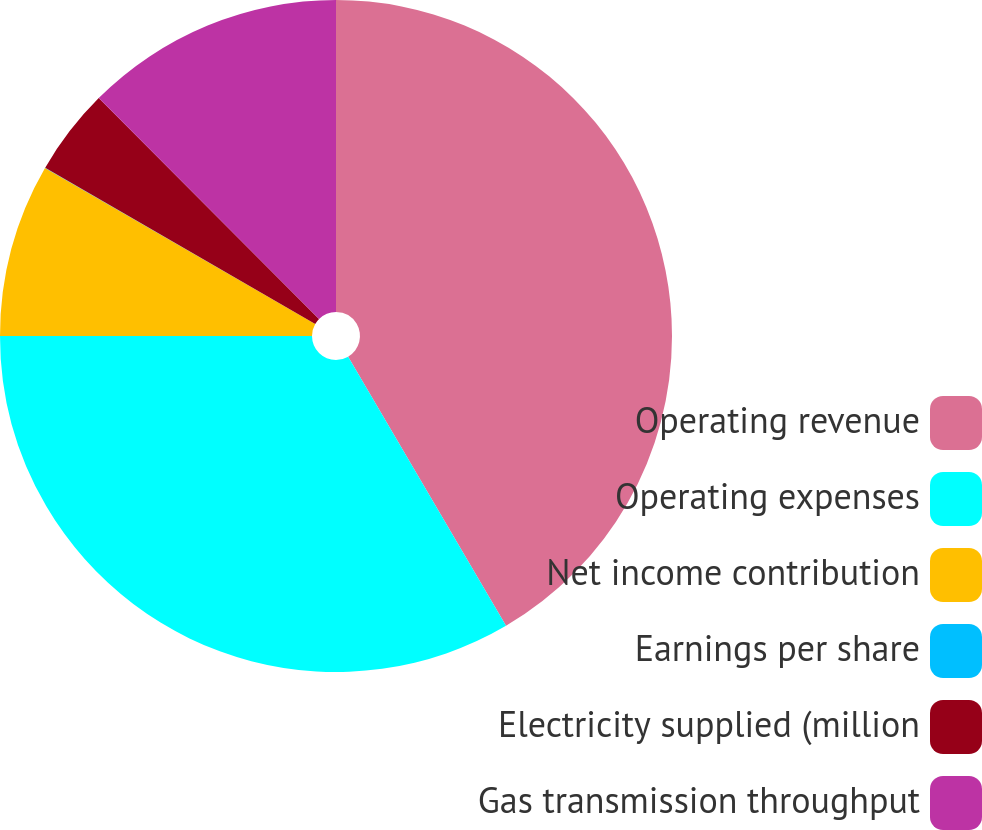<chart> <loc_0><loc_0><loc_500><loc_500><pie_chart><fcel>Operating revenue<fcel>Operating expenses<fcel>Net income contribution<fcel>Earnings per share<fcel>Electricity supplied (million<fcel>Gas transmission throughput<nl><fcel>41.56%<fcel>33.45%<fcel>8.33%<fcel>0.02%<fcel>4.17%<fcel>12.48%<nl></chart> 